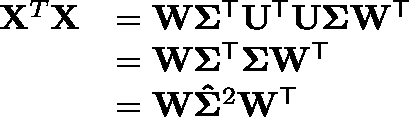Convert formula to latex. <formula><loc_0><loc_0><loc_500><loc_500>{ \begin{array} { r l } { X ^ { T } X } & { = W \Sigma ^ { T } U ^ { T } U \Sigma W ^ { T } } \\ & { = W \Sigma ^ { T } \Sigma W ^ { T } } \\ & { = W \hat { \Sigma } ^ { 2 } W ^ { T } } \end{array} }</formula> 